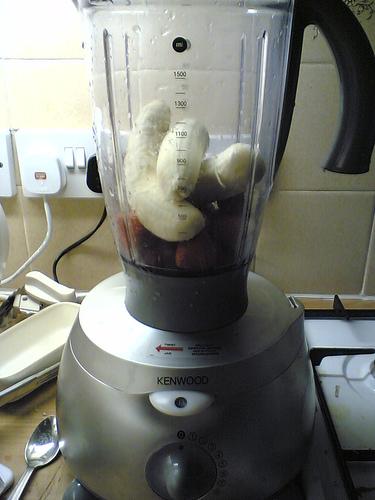Are these items deep fried?
Quick response, please. No. In your own personal opinion, what blended beverage tastes the best when it's hot out?
Short answer required. Smoothie. What breakfast food item is being made in this blender?
Answer briefly. Smoothie. Could these be doughnuts?
Quick response, please. No. What is the function of the items between the two plugs?
Answer briefly. To turn light on or off. What is the quantity that fits in this blender?
Short answer required. 1500. Is there a can behind the mixer?
Keep it brief. No. 